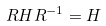<formula> <loc_0><loc_0><loc_500><loc_500>R H R ^ { - 1 } = H</formula> 